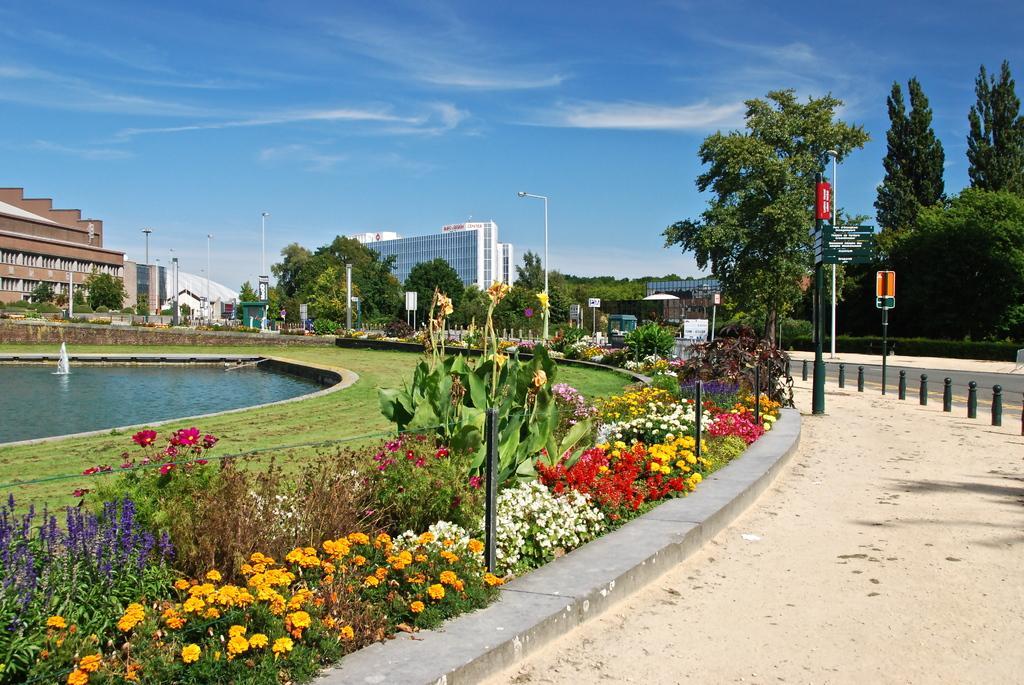Please provide a concise description of this image. In the picture I can see flower plants, trees, poles, street lights and the grass. In the background I can see the water, buildings, the sky and some other objects. 